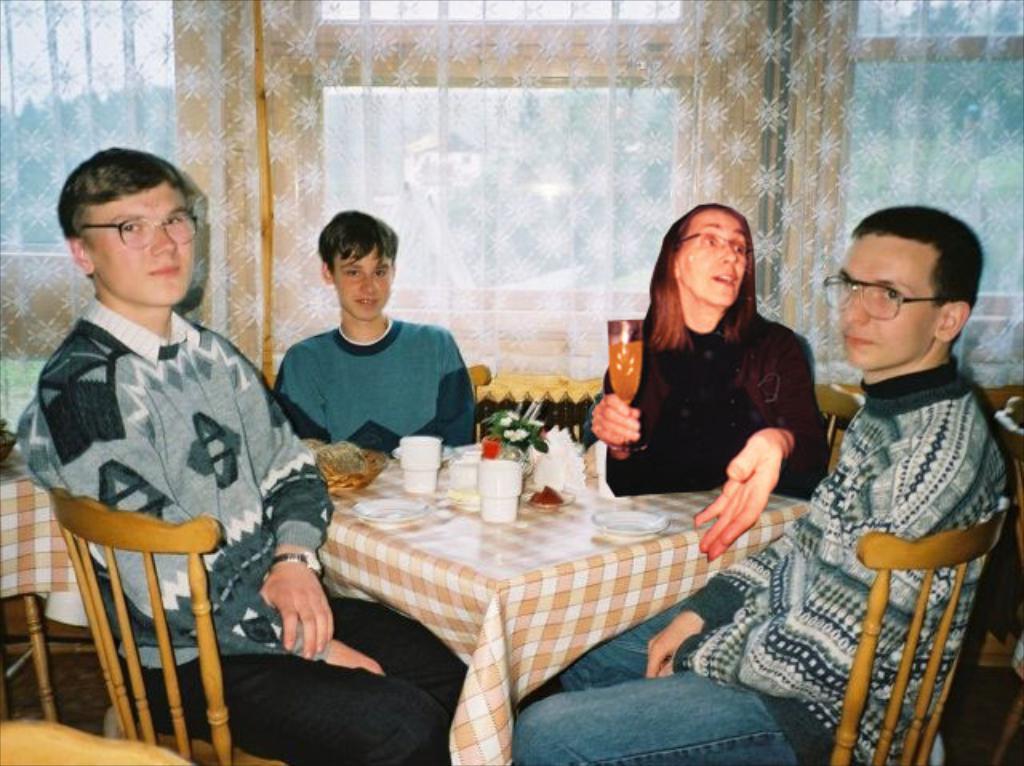Please provide a concise description of this image. in this picture there are four people sitting on the table , there are cups, flowers , tissue papers located on the table. The lady is holding a glass filled with juice. In the background there is a curtain and glass windows surmounted onto the wall. 